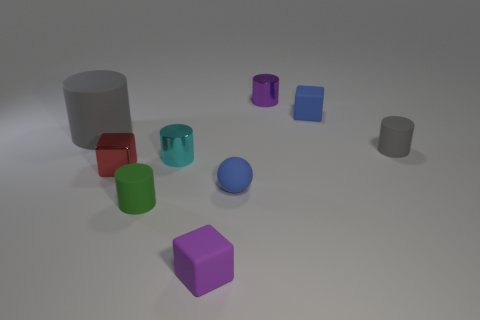There is a cylinder that is on the right side of the tiny purple block and on the left side of the small blue block; how big is it?
Offer a terse response. Small. Is the red object the same shape as the tiny green rubber thing?
Offer a very short reply. No. There is a small gray thing that is the same material as the tiny ball; what shape is it?
Provide a succinct answer. Cylinder. How many small things are either yellow metal balls or purple metallic things?
Offer a very short reply. 1. There is a tiny matte cylinder in front of the small cyan metal cylinder; are there any cyan metal objects that are left of it?
Your response must be concise. No. Is there a small blue sphere?
Make the answer very short. Yes. What color is the cylinder that is to the left of the tiny red metallic thing left of the tiny purple shiny object?
Give a very brief answer. Gray. What material is the blue object that is the same shape as the small purple rubber object?
Make the answer very short. Rubber. How many other blocks are the same size as the blue block?
Keep it short and to the point. 2. The red block that is the same material as the small purple cylinder is what size?
Give a very brief answer. Small. 